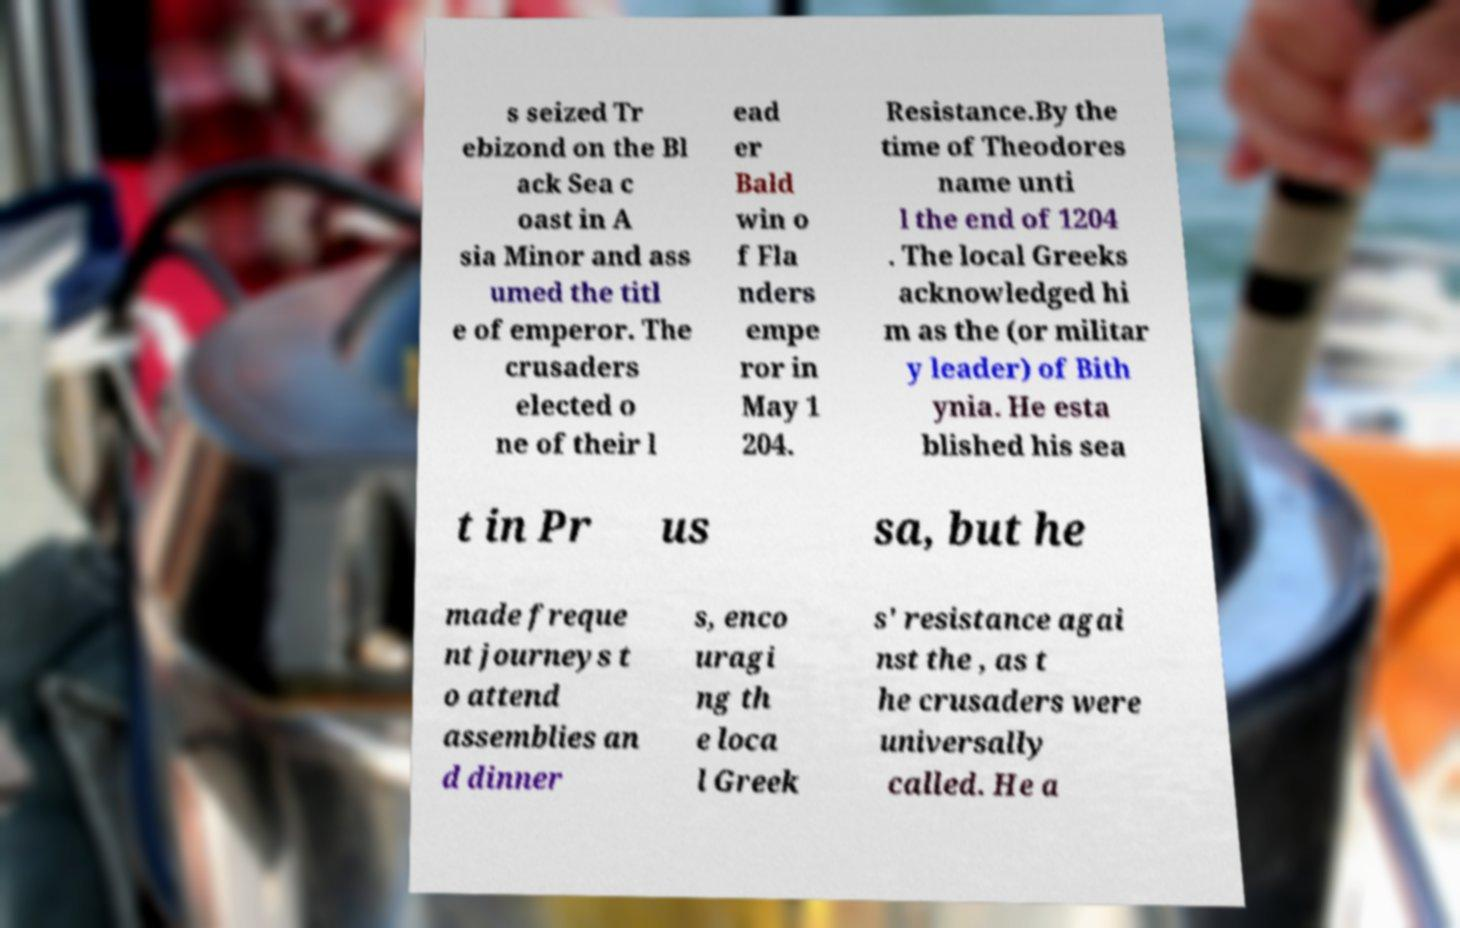Could you extract and type out the text from this image? s seized Tr ebizond on the Bl ack Sea c oast in A sia Minor and ass umed the titl e of emperor. The crusaders elected o ne of their l ead er Bald win o f Fla nders empe ror in May 1 204. Resistance.By the time of Theodores name unti l the end of 1204 . The local Greeks acknowledged hi m as the (or militar y leader) of Bith ynia. He esta blished his sea t in Pr us sa, but he made freque nt journeys t o attend assemblies an d dinner s, enco uragi ng th e loca l Greek s' resistance agai nst the , as t he crusaders were universally called. He a 